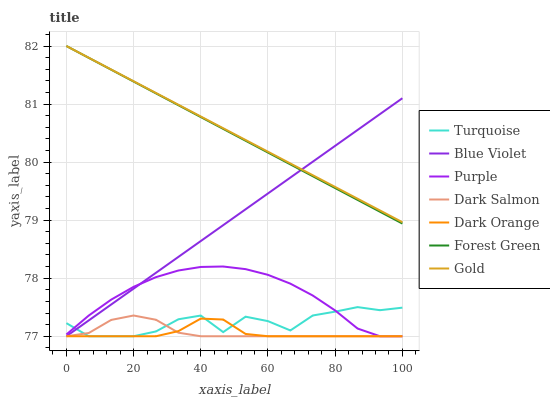Does Dark Orange have the minimum area under the curve?
Answer yes or no. Yes. Does Gold have the maximum area under the curve?
Answer yes or no. Yes. Does Turquoise have the minimum area under the curve?
Answer yes or no. No. Does Turquoise have the maximum area under the curve?
Answer yes or no. No. Is Blue Violet the smoothest?
Answer yes or no. Yes. Is Turquoise the roughest?
Answer yes or no. Yes. Is Gold the smoothest?
Answer yes or no. No. Is Gold the roughest?
Answer yes or no. No. Does Dark Orange have the lowest value?
Answer yes or no. Yes. Does Gold have the lowest value?
Answer yes or no. No. Does Forest Green have the highest value?
Answer yes or no. Yes. Does Turquoise have the highest value?
Answer yes or no. No. Is Dark Orange less than Gold?
Answer yes or no. Yes. Is Gold greater than Dark Salmon?
Answer yes or no. Yes. Does Purple intersect Dark Orange?
Answer yes or no. Yes. Is Purple less than Dark Orange?
Answer yes or no. No. Is Purple greater than Dark Orange?
Answer yes or no. No. Does Dark Orange intersect Gold?
Answer yes or no. No. 